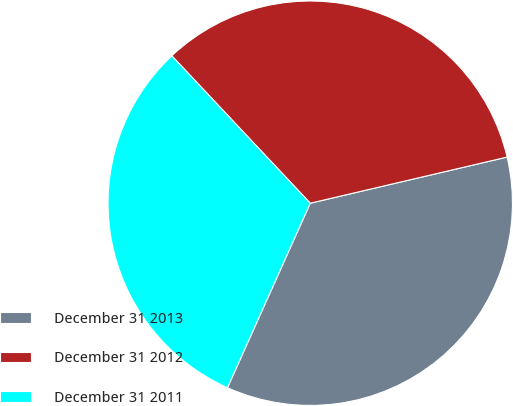<chart> <loc_0><loc_0><loc_500><loc_500><pie_chart><fcel>December 31 2013<fcel>December 31 2012<fcel>December 31 2011<nl><fcel>35.38%<fcel>33.34%<fcel>31.29%<nl></chart> 